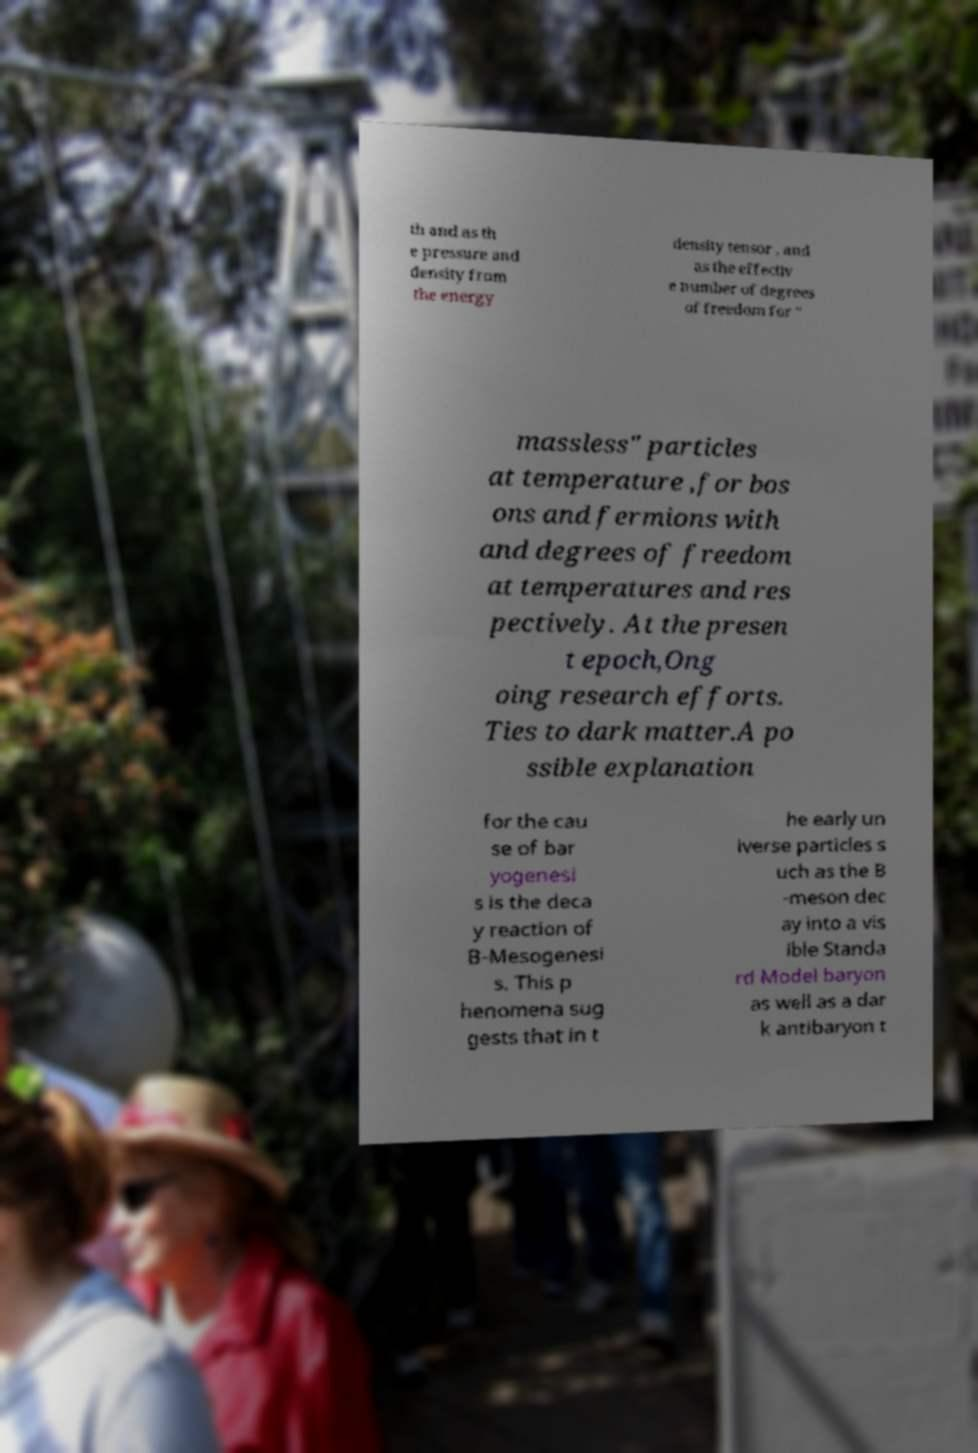For documentation purposes, I need the text within this image transcribed. Could you provide that? th and as th e pressure and density from the energy density tensor , and as the effectiv e number of degrees of freedom for " massless" particles at temperature ,for bos ons and fermions with and degrees of freedom at temperatures and res pectively. At the presen t epoch,Ong oing research efforts. Ties to dark matter.A po ssible explanation for the cau se of bar yogenesi s is the deca y reaction of B-Mesogenesi s. This p henomena sug gests that in t he early un iverse particles s uch as the B -meson dec ay into a vis ible Standa rd Model baryon as well as a dar k antibaryon t 